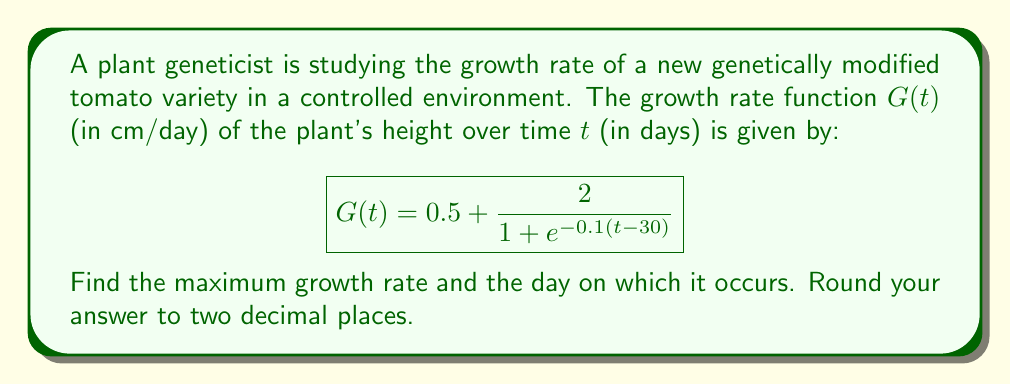Can you solve this math problem? To find the maximum growth rate and the day it occurs, we need to follow these steps:

1) First, we need to find the derivative of the growth rate function $G(t)$:

   $$G'(t) = \frac{d}{dt}\left(0.5 + \frac{2}{1 + e^{-0.1(t-30)}}\right)$$

   $$G'(t) = 0 + 2 \cdot \frac{d}{dt}\left(\frac{1}{1 + e^{-0.1(t-30)}}\right)$$

   Using the chain rule:

   $$G'(t) = 2 \cdot \frac{0.1e^{-0.1(t-30)}}{(1 + e^{-0.1(t-30)})^2}$$

2) To find the maximum growth rate, we need to find where $G'(t) = 0$:

   $$2 \cdot \frac{0.1e^{-0.1(t-30)}}{(1 + e^{-0.1(t-30)})^2} = 0$$

   This equation is satisfied when $e^{-0.1(t-30)} = 0$, which occurs as $t$ approaches infinity. However, we're looking for a finite maximum.

3) In this case, the maximum occurs at the inflection point of $G(t)$, which is when $t = 30$ (the midpoint of the logistic function).

4) To find the maximum growth rate, we substitute $t = 30$ into $G(t)$:

   $$G(30) = 0.5 + \frac{2}{1 + e^{-0.1(30-30)}} = 0.5 + \frac{2}{1 + e^0} = 0.5 + 1 = 1.5$$

Therefore, the maximum growth rate is 1.5 cm/day, occurring on day 30.
Answer: 1.50 cm/day on day 30 